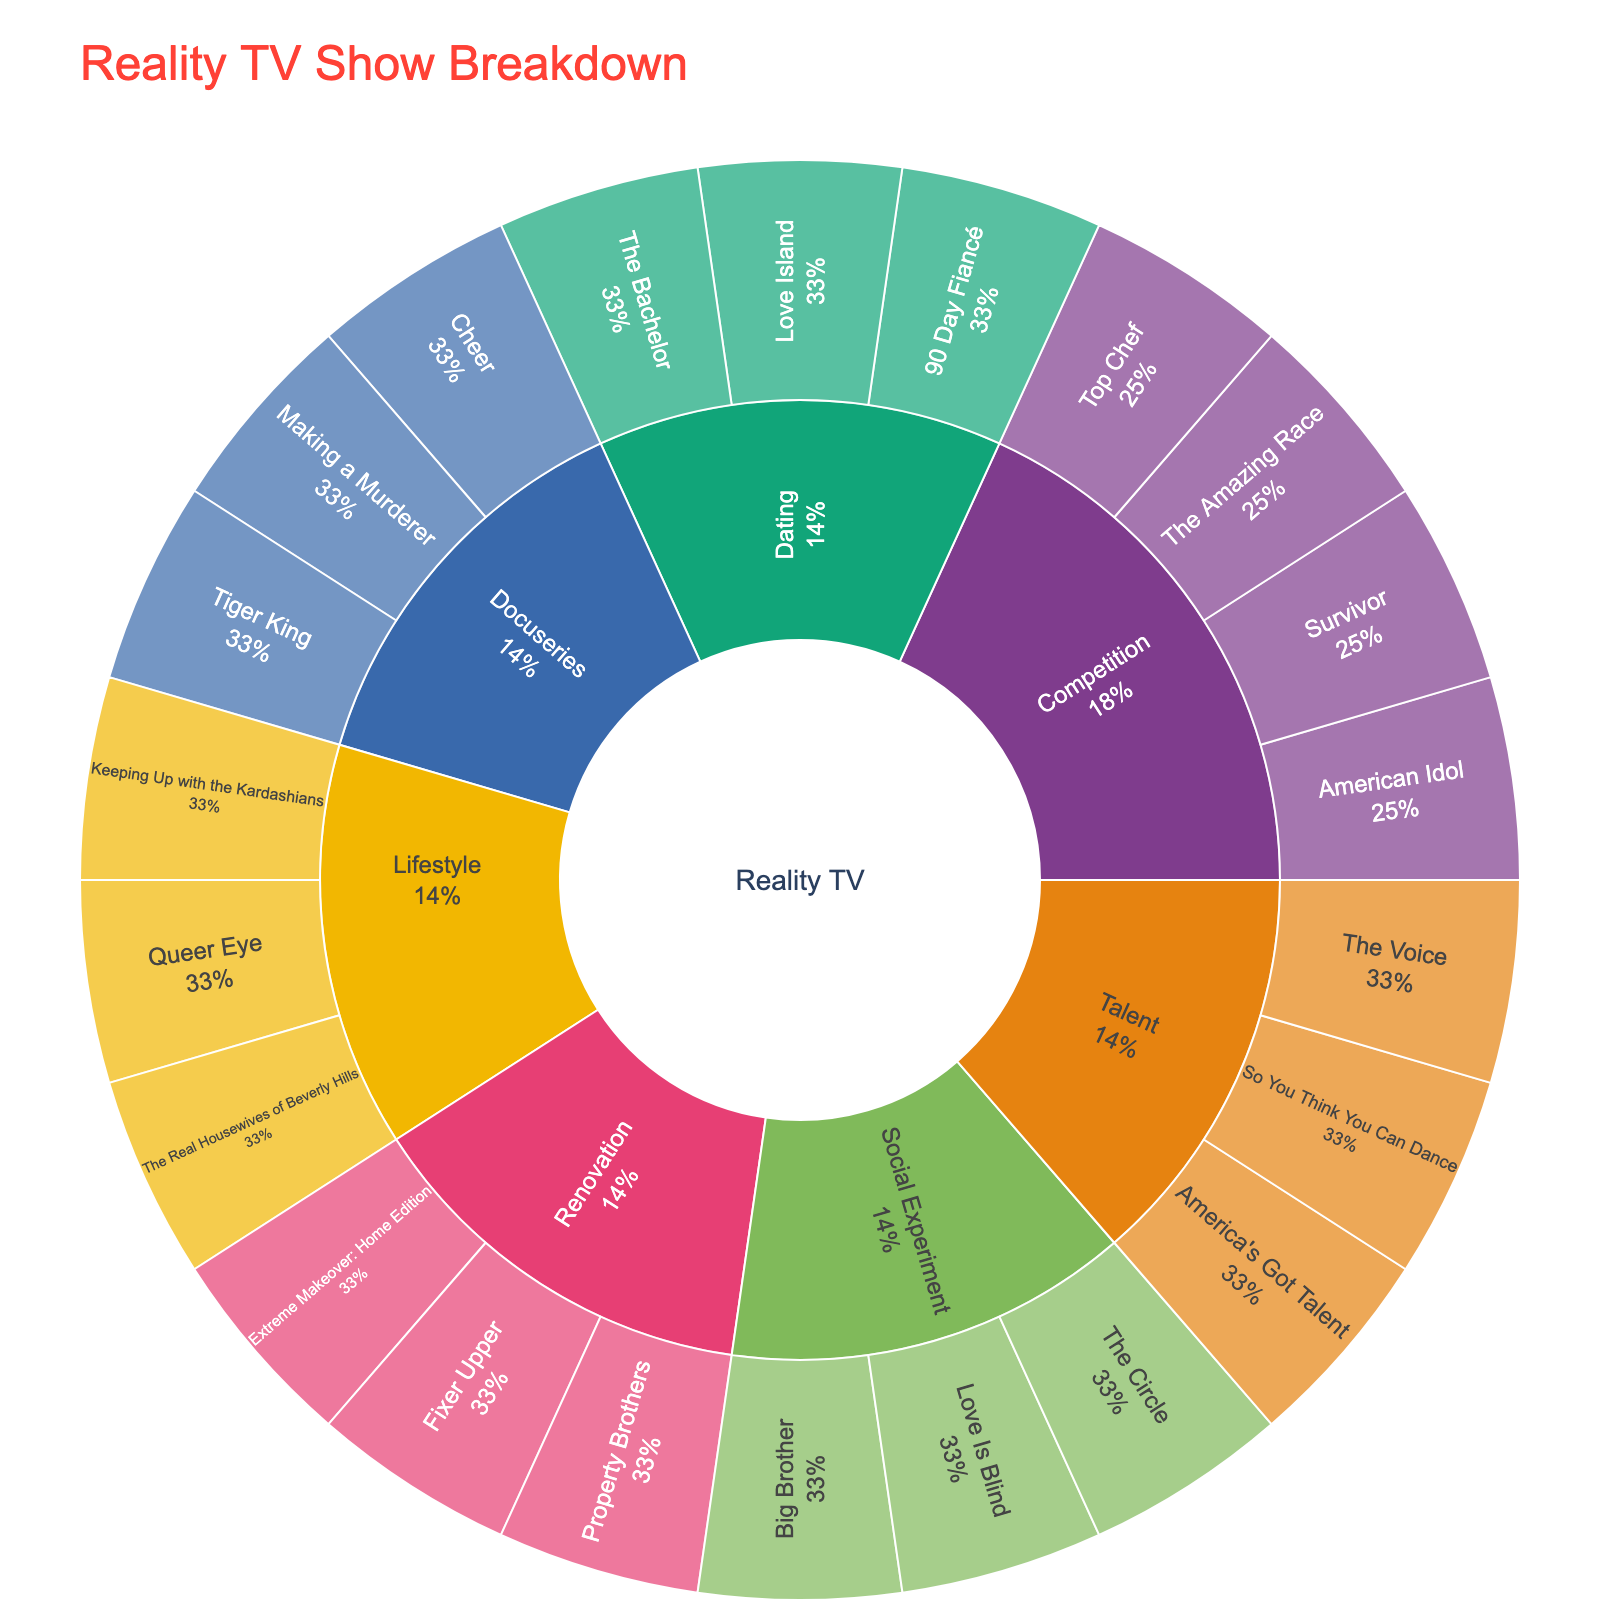How many categories are there in the Sunburst Plot? The plot shows the primary level of the sunburst, which consists of the main categories for Reality TV show genres. Counting them gives the number of categories.
Answer: 1 What are the subcategories under the 'Lifestyle' category? By observing the second level within the 'Lifestyle' category, you can list all subcategories that fall under it.
Answer: Keeping Up with the Kardashians, The Real Housewives of Beverly Hills, Queer Eye Which category has the most subgenres? Count the number of subgenres (second level) for each main category from the plot and compare them.
Answer: Reality TV, since all subcategories are under it What percentage of shows are in the 'Dating' subcategory? Each segment in the sunburst indicates the number of shows. Count the shows in the 'Dating' subcategory and divide by the total number of shows, then multiply by 100 to find the percentage.
Answer: 15% Which subcategory contains the show 'Tiger King'? Find the segment that includes 'Tiger King' and look at its parent's label to determine the subcategory.
Answer: Docuseries Compare the number of shows in 'Competition' subcategory versus 'Renovation' subcategory. Count the number of shows in both 'Competition' and 'Renovation' subcategories and compare them.
Answer: Competition has 4 shows; Renovation has 3 shows What are the shows listed under 'Talent' subcategory? Look at the third level within the 'Talent' subcategory to list all the shows under it.
Answer: America's Got Talent, The Voice, So You Think You Can Dance Are there more shows in the 'Social Experiment' or 'Docuseries' subcategory? Count the number of shows in both 'Social Experiment' and 'Docuseries' subcategories and compare which has more.
Answer: Social Experiment (3) has more than Docuseries (3) 